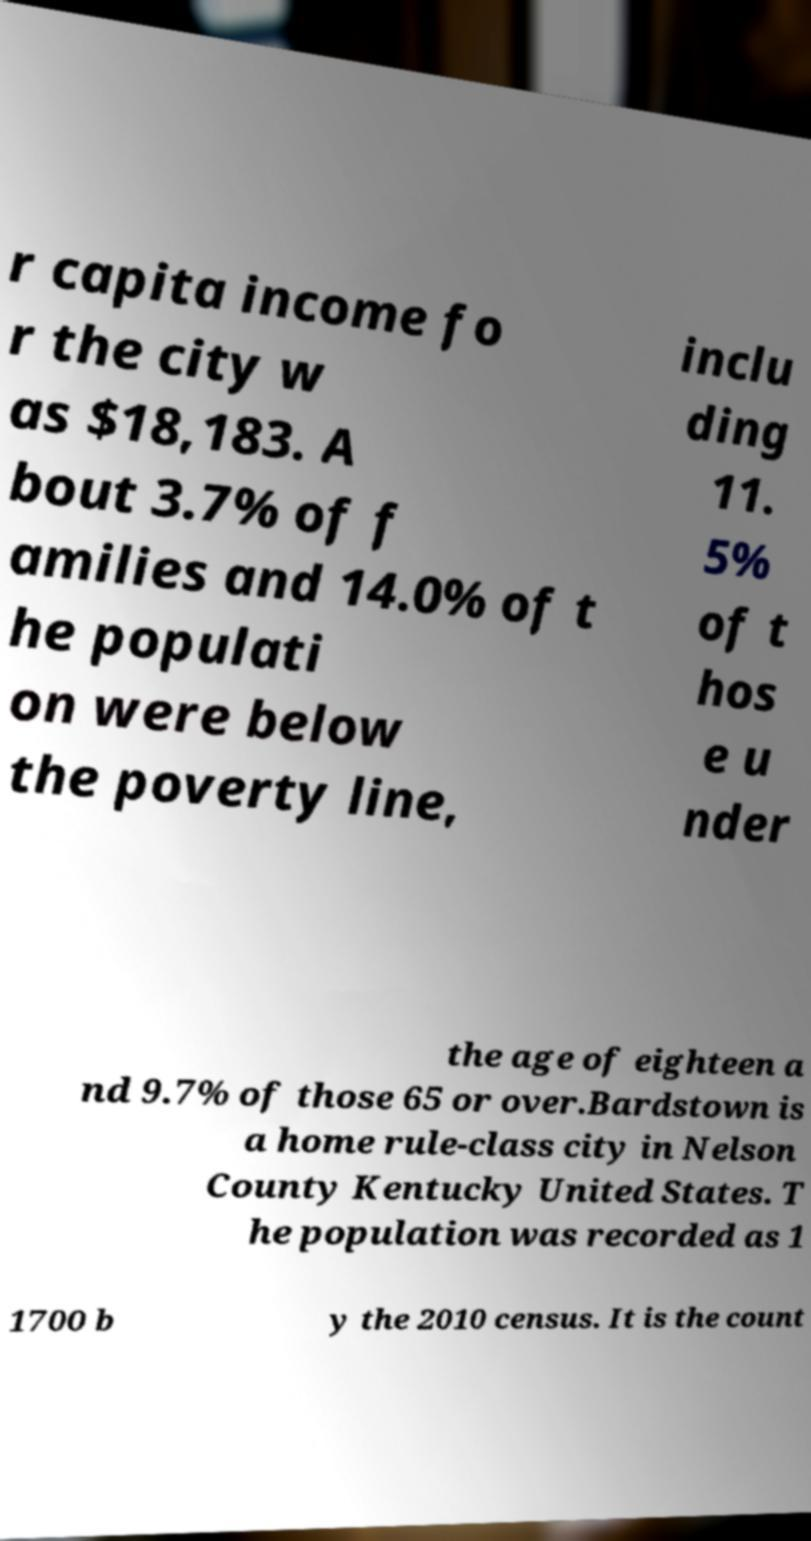Could you assist in decoding the text presented in this image and type it out clearly? r capita income fo r the city w as $18,183. A bout 3.7% of f amilies and 14.0% of t he populati on were below the poverty line, inclu ding 11. 5% of t hos e u nder the age of eighteen a nd 9.7% of those 65 or over.Bardstown is a home rule-class city in Nelson County Kentucky United States. T he population was recorded as 1 1700 b y the 2010 census. It is the count 